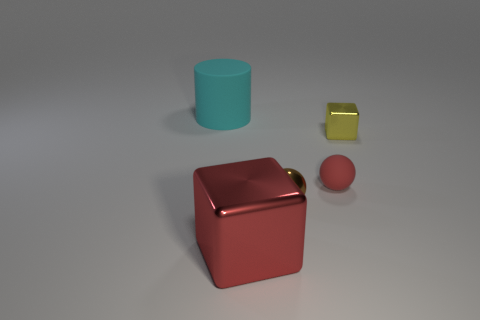Does the shiny cube that is on the left side of the red sphere have the same size as the yellow metal cube?
Provide a succinct answer. No. What color is the metallic block that is on the left side of the metal block behind the big object in front of the large cylinder?
Offer a very short reply. Red. The large cube has what color?
Offer a terse response. Red. Do the metallic ball and the rubber cylinder have the same color?
Ensure brevity in your answer.  No. Is the thing behind the small metallic cube made of the same material as the cube that is on the right side of the large red block?
Make the answer very short. No. There is a red object that is the same shape as the tiny yellow metal object; what is its material?
Make the answer very short. Metal. Do the big cyan cylinder and the red ball have the same material?
Keep it short and to the point. Yes. What color is the matte object in front of the matte object on the left side of the small brown shiny thing?
Keep it short and to the point. Red. What size is the ball that is made of the same material as the large block?
Your answer should be compact. Small. How many big cyan matte things have the same shape as the small red matte thing?
Your response must be concise. 0. 